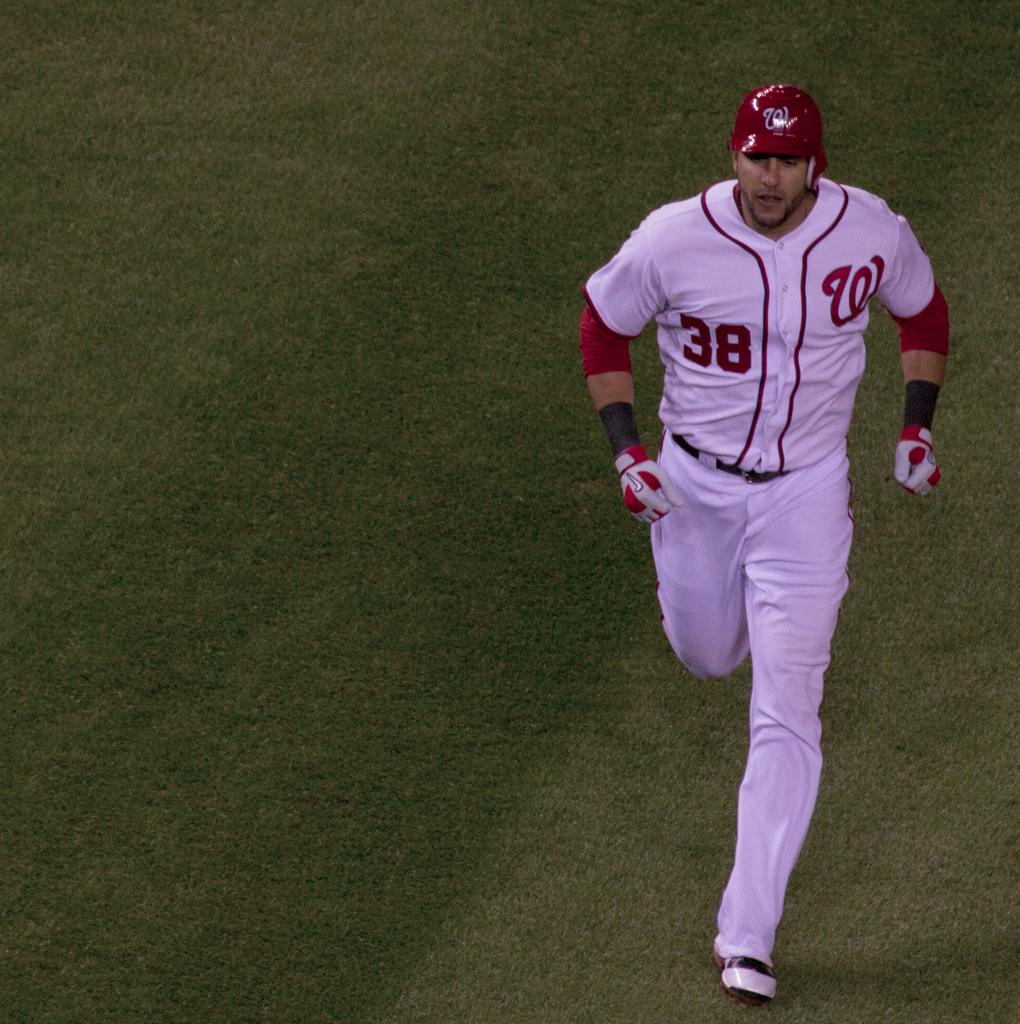What player number is this runner?
Your answer should be compact. 38. Is that a w on his cap?
Your response must be concise. Yes. 